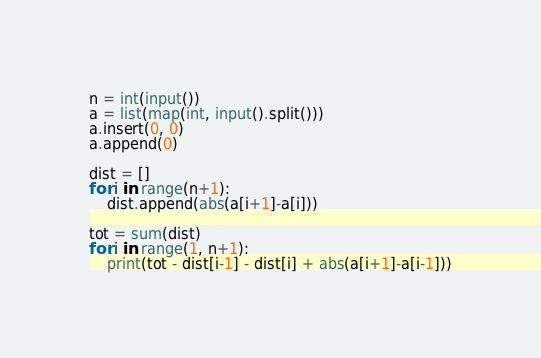Convert code to text. <code><loc_0><loc_0><loc_500><loc_500><_Python_>n = int(input())
a = list(map(int, input().split()))
a.insert(0, 0)
a.append(0)

dist = []
for i in range(n+1):
    dist.append(abs(a[i+1]-a[i]))

tot = sum(dist)
for i in range(1, n+1):
    print(tot - dist[i-1] - dist[i] + abs(a[i+1]-a[i-1]))</code> 